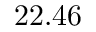Convert formula to latex. <formula><loc_0><loc_0><loc_500><loc_500>2 2 . 4 6</formula> 